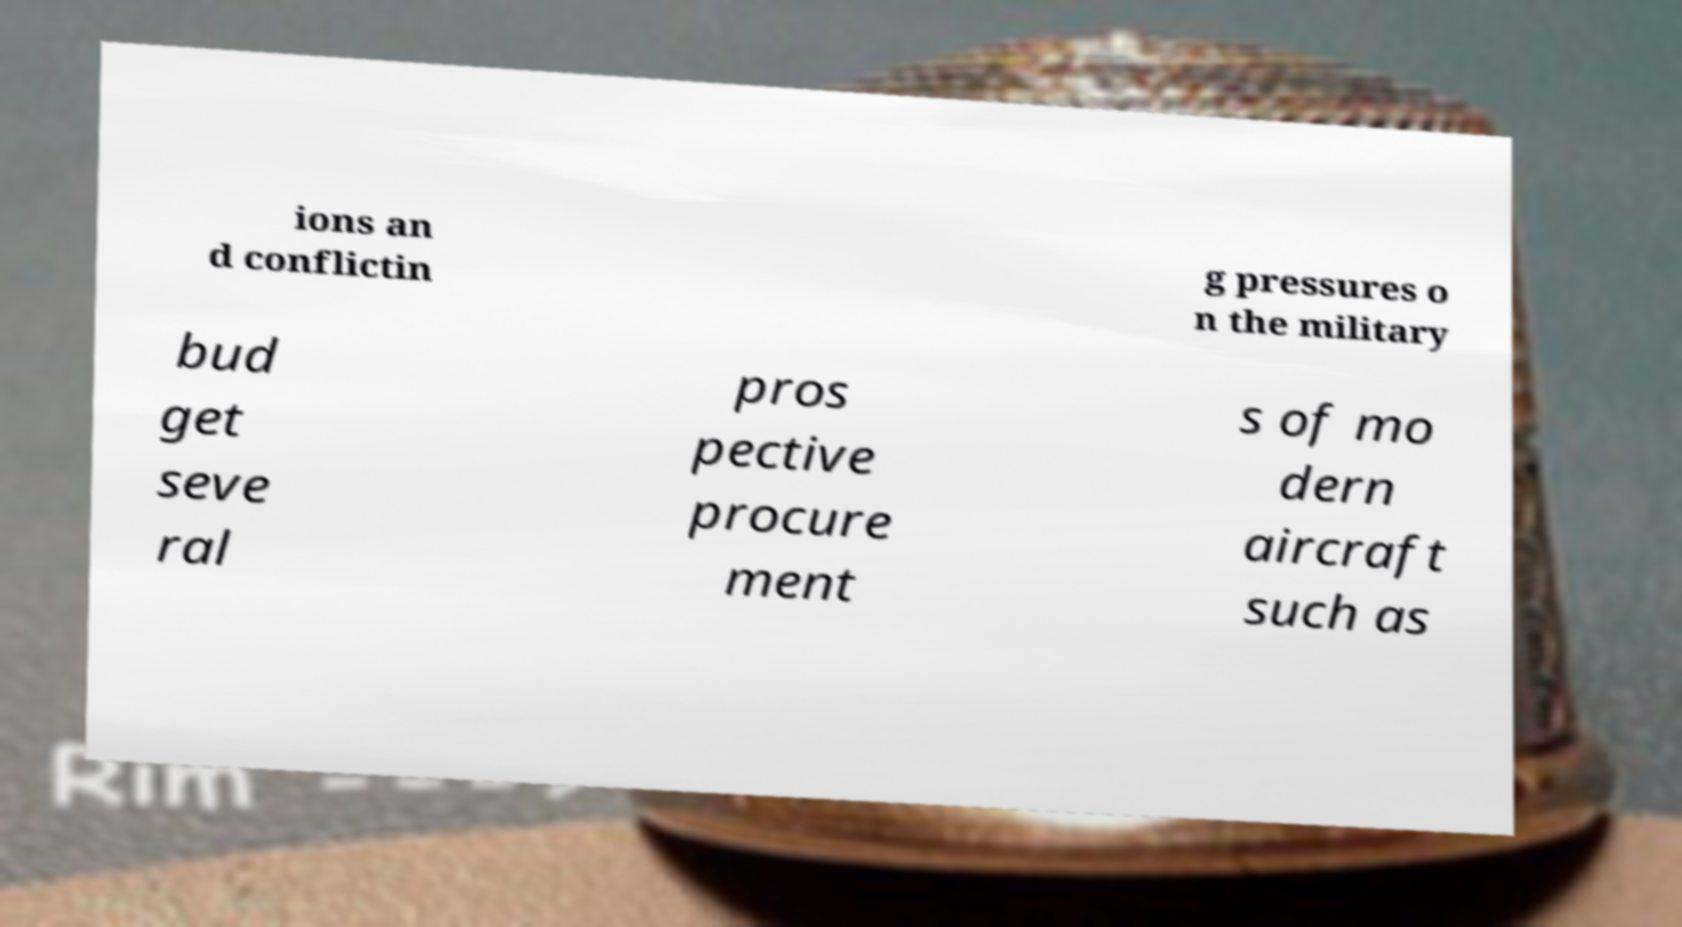Could you assist in decoding the text presented in this image and type it out clearly? ions an d conflictin g pressures o n the military bud get seve ral pros pective procure ment s of mo dern aircraft such as 